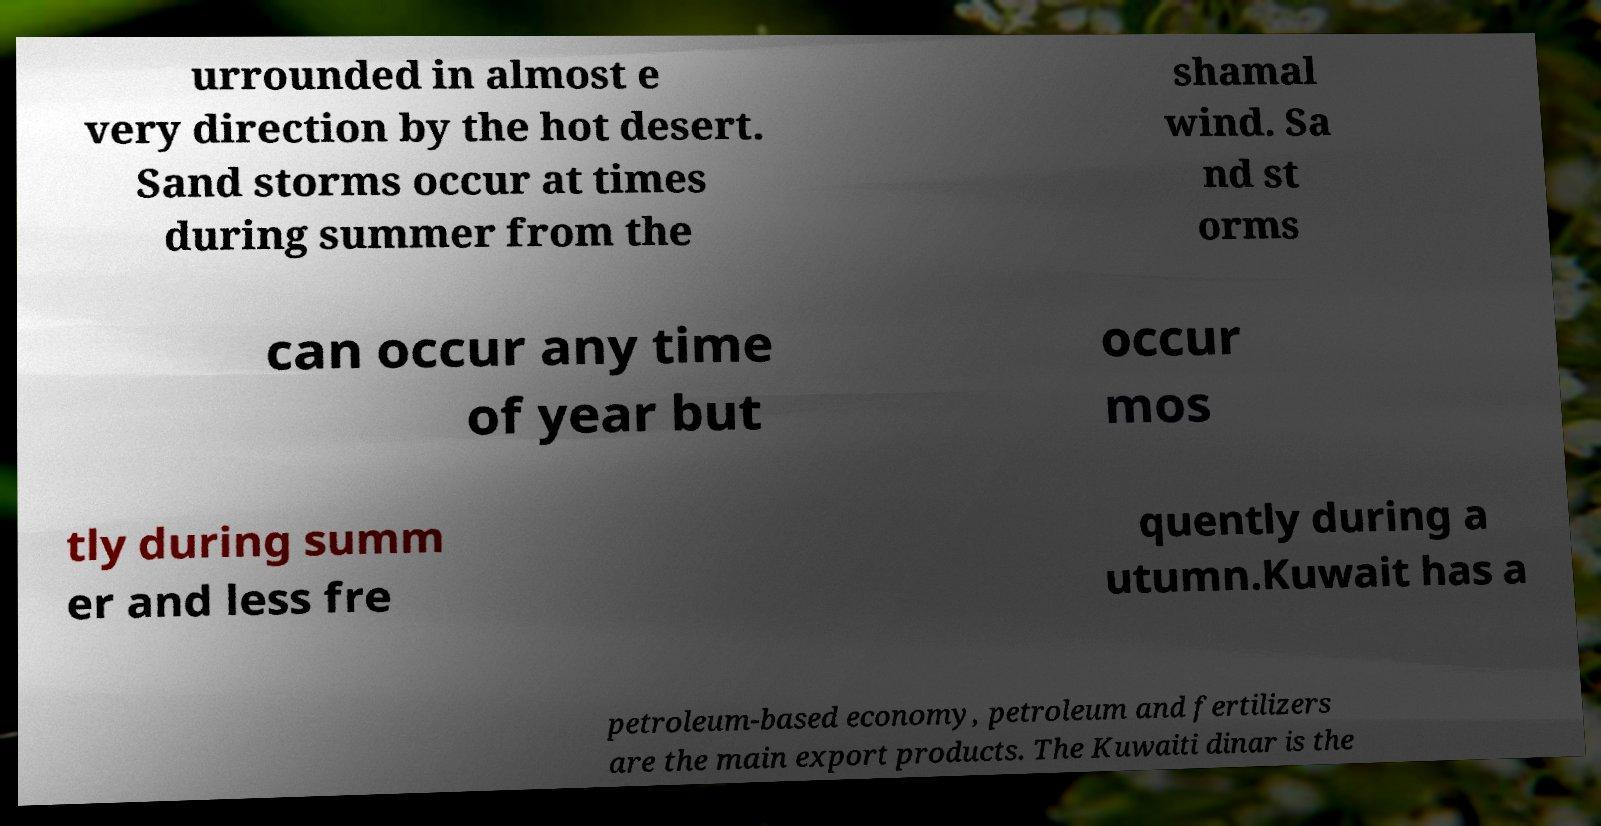Can you read and provide the text displayed in the image?This photo seems to have some interesting text. Can you extract and type it out for me? urrounded in almost e very direction by the hot desert. Sand storms occur at times during summer from the shamal wind. Sa nd st orms can occur any time of year but occur mos tly during summ er and less fre quently during a utumn.Kuwait has a petroleum-based economy, petroleum and fertilizers are the main export products. The Kuwaiti dinar is the 